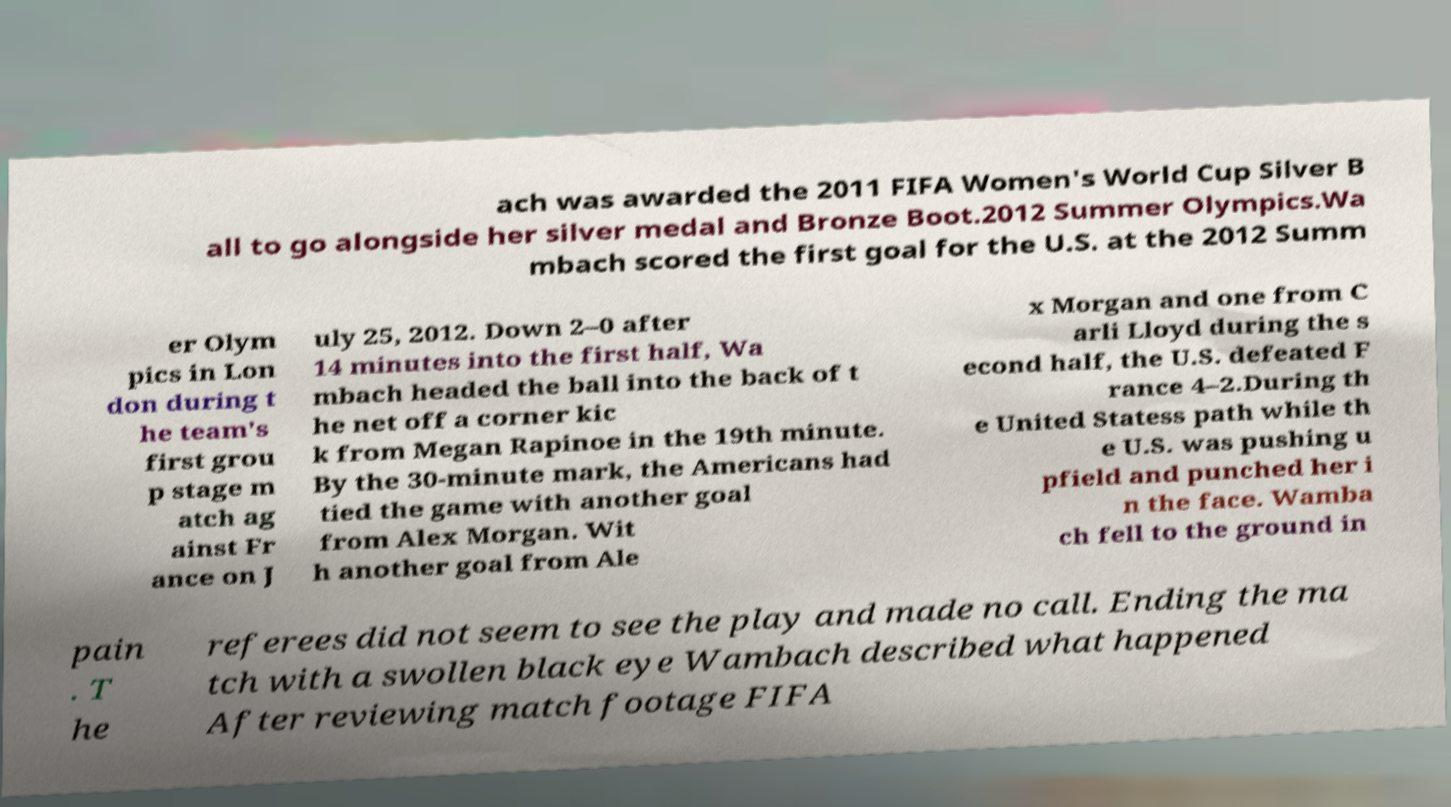I need the written content from this picture converted into text. Can you do that? ach was awarded the 2011 FIFA Women's World Cup Silver B all to go alongside her silver medal and Bronze Boot.2012 Summer Olympics.Wa mbach scored the first goal for the U.S. at the 2012 Summ er Olym pics in Lon don during t he team's first grou p stage m atch ag ainst Fr ance on J uly 25, 2012. Down 2–0 after 14 minutes into the first half, Wa mbach headed the ball into the back of t he net off a corner kic k from Megan Rapinoe in the 19th minute. By the 30-minute mark, the Americans had tied the game with another goal from Alex Morgan. Wit h another goal from Ale x Morgan and one from C arli Lloyd during the s econd half, the U.S. defeated F rance 4–2.During th e United Statess path while th e U.S. was pushing u pfield and punched her i n the face. Wamba ch fell to the ground in pain . T he referees did not seem to see the play and made no call. Ending the ma tch with a swollen black eye Wambach described what happened After reviewing match footage FIFA 